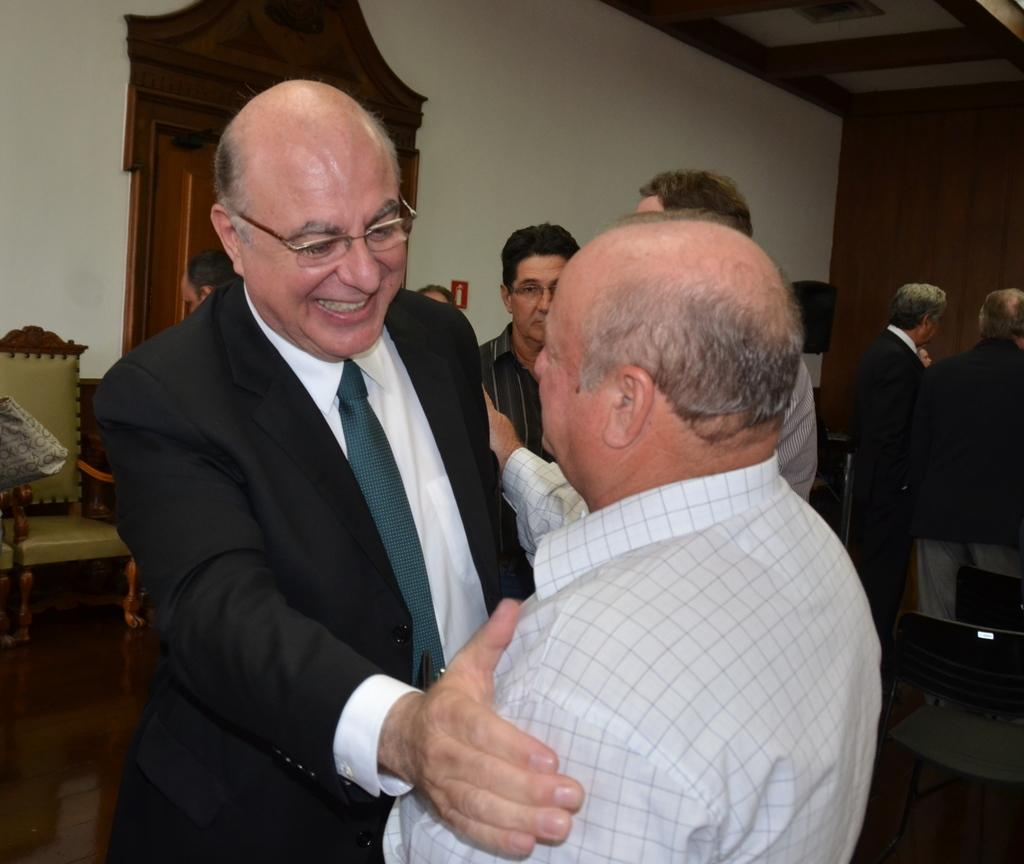What are the two people in the image doing? The two people in the image are holding each other. What is the person wearing a suit doing? The person in the suit is smiling. Can you describe the background of the image? In the background of the image, there are people, chairs, objects, a wall, and a floor. How many people are visible in the image? There are two people holding each other, and there are additional people visible in the background. What type of straw is being used by the person in the suit? There is no straw present in the image. Does the existence of the house in the image prove the existence of a parallel universe? There is no mention of a house in the image, and therefore it cannot be used to prove the existence of a parallel universe. 